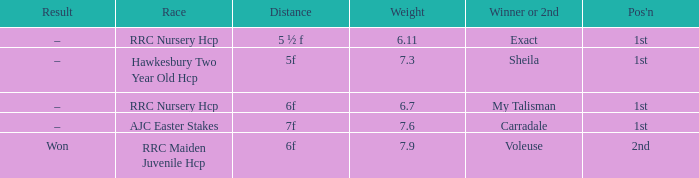What was the separation when the load was 5 ½ f. Can you give me this table as a dict? {'header': ['Result', 'Race', 'Distance', 'Weight', 'Winner or 2nd', "Pos'n"], 'rows': [['–', 'RRC Nursery Hcp', '5 ½ f', '6.11', 'Exact', '1st'], ['–', 'Hawkesbury Two Year Old Hcp', '5f', '7.3', 'Sheila', '1st'], ['–', 'RRC Nursery Hcp', '6f', '6.7', 'My Talisman', '1st'], ['–', 'AJC Easter Stakes', '7f', '7.6', 'Carradale', '1st'], ['Won', 'RRC Maiden Juvenile Hcp', '6f', '7.9', 'Voleuse', '2nd']]} 